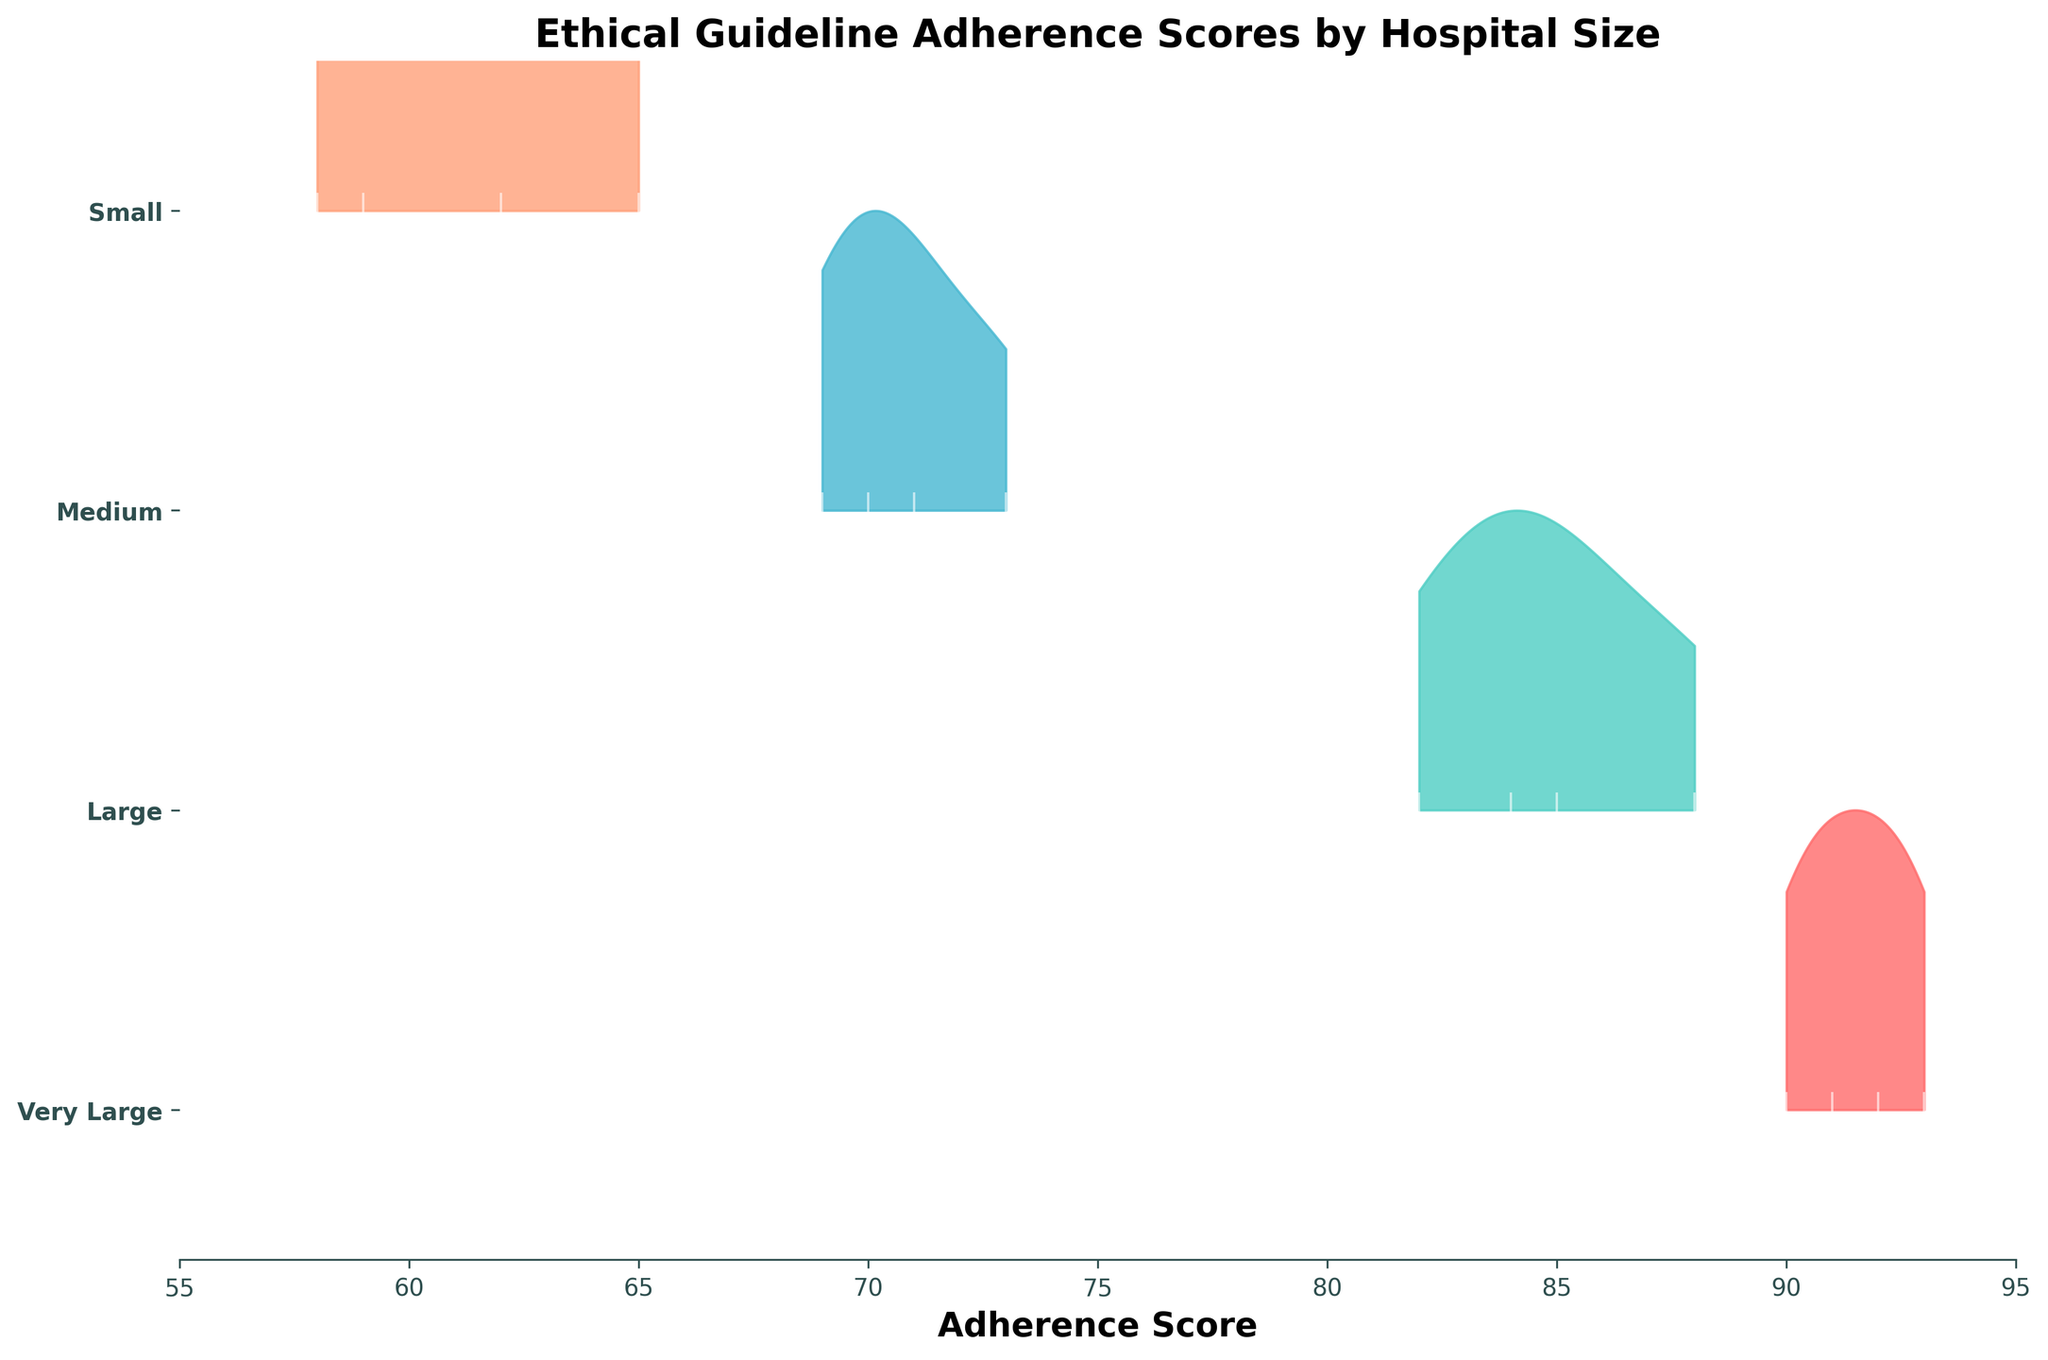What is the title of the plot? The title is located at the top of the plot, and it describes the main topic of the visualization.
Answer: Ethical Guideline Adherence Scores by Hospital Size Which hospital size category has the highest peak in adherence scores? The highest peak can be identified by comparing the maximum density heights for the different hospital size categories in the plot.
Answer: Very Large What is the range of adherence scores for Small hospitals? The range of adherence scores can be identified from the x-axis values where the data points (in this case, vertical white lines) for Small hospitals are plotted.
Answer: 58 to 65 Which hospital size categories have data points plotted in between 85 to 90 on the x-axis? Identify the categories by examining where the vertical white lines fall between the adherence score values of 85 and 90.
Answer: Large and Very Large What is the difference in the maximum adherence scores between Small and Very Large hospitals? Find the maximum adherence scores for both categories by locating the furthest data points to the right on the x-axis and calculate the difference.
Answer: 93 - 65 = 28 How does the adherence score distribution of Medium hospitals compare to Large hospitals? Compare the shape and position of the ridgeline plots for Medium and Large hospitals in terms of their heights and spread along the x-axis.
Answer: Large hospitals have higher scores on average and a tighter distribution Which hospital size has the least variation in adherence scores, and how do you know? Identify the hospital size with the narrowest spread (range) in adherence scores by examining the width of the ridgeline plots.
Answer: Large hospitals Do any hospital size categories have overlapping adherence scores, and if so, which ones? Look for ridgeline plots or data points from different categories that lie within the same range on the x-axis.
Answer: Medium and Large How many adherence score data points are present for Very Large hospitals? Count the vertical white lines within the Very Large hospital ridgeline plot.
Answer: 4 Which hospital size category has the lowest average adherence score? Estimate by examining the central tendency (average position) of the ridgeline plots for each hospital size category and comparing them.
Answer: Small 